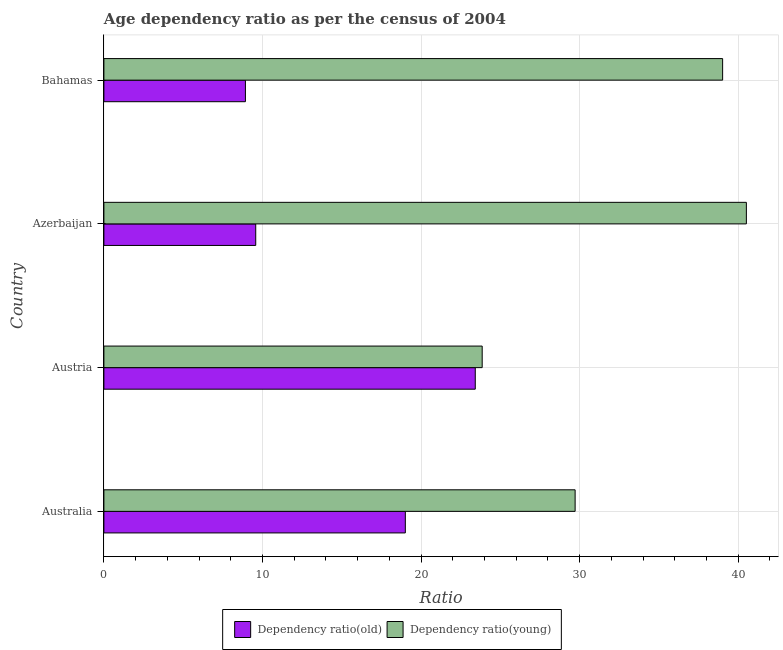Are the number of bars on each tick of the Y-axis equal?
Provide a succinct answer. Yes. How many bars are there on the 2nd tick from the top?
Your answer should be very brief. 2. How many bars are there on the 4th tick from the bottom?
Provide a succinct answer. 2. What is the age dependency ratio(young) in Austria?
Provide a short and direct response. 23.86. Across all countries, what is the maximum age dependency ratio(old)?
Make the answer very short. 23.42. Across all countries, what is the minimum age dependency ratio(young)?
Ensure brevity in your answer.  23.86. In which country was the age dependency ratio(young) maximum?
Offer a terse response. Azerbaijan. What is the total age dependency ratio(young) in the graph?
Provide a short and direct response. 133.12. What is the difference between the age dependency ratio(young) in Azerbaijan and that in Bahamas?
Make the answer very short. 1.5. What is the difference between the age dependency ratio(old) in Australia and the age dependency ratio(young) in Bahamas?
Offer a very short reply. -20.01. What is the average age dependency ratio(old) per country?
Ensure brevity in your answer.  15.23. What is the difference between the age dependency ratio(old) and age dependency ratio(young) in Azerbaijan?
Your answer should be very brief. -30.94. What is the ratio of the age dependency ratio(old) in Australia to that in Austria?
Ensure brevity in your answer.  0.81. What is the difference between the highest and the second highest age dependency ratio(young)?
Keep it short and to the point. 1.5. What is the difference between the highest and the lowest age dependency ratio(young)?
Ensure brevity in your answer.  16.66. In how many countries, is the age dependency ratio(old) greater than the average age dependency ratio(old) taken over all countries?
Give a very brief answer. 2. What does the 1st bar from the top in Australia represents?
Your response must be concise. Dependency ratio(young). What does the 2nd bar from the bottom in Austria represents?
Ensure brevity in your answer.  Dependency ratio(young). How many bars are there?
Your answer should be very brief. 8. What is the difference between two consecutive major ticks on the X-axis?
Provide a short and direct response. 10. Are the values on the major ticks of X-axis written in scientific E-notation?
Your answer should be very brief. No. Does the graph contain any zero values?
Keep it short and to the point. No. Where does the legend appear in the graph?
Offer a very short reply. Bottom center. What is the title of the graph?
Offer a very short reply. Age dependency ratio as per the census of 2004. What is the label or title of the X-axis?
Your response must be concise. Ratio. What is the Ratio of Dependency ratio(old) in Australia?
Offer a terse response. 19.01. What is the Ratio in Dependency ratio(young) in Australia?
Keep it short and to the point. 29.72. What is the Ratio in Dependency ratio(old) in Austria?
Your answer should be compact. 23.42. What is the Ratio of Dependency ratio(young) in Austria?
Keep it short and to the point. 23.86. What is the Ratio of Dependency ratio(old) in Azerbaijan?
Provide a succinct answer. 9.58. What is the Ratio in Dependency ratio(young) in Azerbaijan?
Ensure brevity in your answer.  40.52. What is the Ratio of Dependency ratio(old) in Bahamas?
Your answer should be very brief. 8.93. What is the Ratio of Dependency ratio(young) in Bahamas?
Make the answer very short. 39.02. Across all countries, what is the maximum Ratio in Dependency ratio(old)?
Provide a succinct answer. 23.42. Across all countries, what is the maximum Ratio of Dependency ratio(young)?
Keep it short and to the point. 40.52. Across all countries, what is the minimum Ratio of Dependency ratio(old)?
Your answer should be very brief. 8.93. Across all countries, what is the minimum Ratio of Dependency ratio(young)?
Offer a very short reply. 23.86. What is the total Ratio in Dependency ratio(old) in the graph?
Offer a terse response. 60.94. What is the total Ratio in Dependency ratio(young) in the graph?
Offer a very short reply. 133.12. What is the difference between the Ratio of Dependency ratio(old) in Australia and that in Austria?
Offer a terse response. -4.41. What is the difference between the Ratio in Dependency ratio(young) in Australia and that in Austria?
Your response must be concise. 5.86. What is the difference between the Ratio in Dependency ratio(old) in Australia and that in Azerbaijan?
Your response must be concise. 9.43. What is the difference between the Ratio in Dependency ratio(young) in Australia and that in Azerbaijan?
Offer a terse response. -10.8. What is the difference between the Ratio of Dependency ratio(old) in Australia and that in Bahamas?
Keep it short and to the point. 10.08. What is the difference between the Ratio in Dependency ratio(young) in Australia and that in Bahamas?
Your answer should be very brief. -9.3. What is the difference between the Ratio in Dependency ratio(old) in Austria and that in Azerbaijan?
Your answer should be very brief. 13.85. What is the difference between the Ratio in Dependency ratio(young) in Austria and that in Azerbaijan?
Offer a terse response. -16.66. What is the difference between the Ratio of Dependency ratio(old) in Austria and that in Bahamas?
Your answer should be very brief. 14.5. What is the difference between the Ratio in Dependency ratio(young) in Austria and that in Bahamas?
Give a very brief answer. -15.16. What is the difference between the Ratio of Dependency ratio(old) in Azerbaijan and that in Bahamas?
Keep it short and to the point. 0.65. What is the difference between the Ratio in Dependency ratio(young) in Azerbaijan and that in Bahamas?
Ensure brevity in your answer.  1.5. What is the difference between the Ratio in Dependency ratio(old) in Australia and the Ratio in Dependency ratio(young) in Austria?
Your answer should be compact. -4.85. What is the difference between the Ratio in Dependency ratio(old) in Australia and the Ratio in Dependency ratio(young) in Azerbaijan?
Your response must be concise. -21.51. What is the difference between the Ratio in Dependency ratio(old) in Australia and the Ratio in Dependency ratio(young) in Bahamas?
Offer a terse response. -20.01. What is the difference between the Ratio of Dependency ratio(old) in Austria and the Ratio of Dependency ratio(young) in Azerbaijan?
Give a very brief answer. -17.1. What is the difference between the Ratio of Dependency ratio(old) in Austria and the Ratio of Dependency ratio(young) in Bahamas?
Offer a very short reply. -15.6. What is the difference between the Ratio of Dependency ratio(old) in Azerbaijan and the Ratio of Dependency ratio(young) in Bahamas?
Your response must be concise. -29.45. What is the average Ratio of Dependency ratio(old) per country?
Make the answer very short. 15.23. What is the average Ratio of Dependency ratio(young) per country?
Ensure brevity in your answer.  33.28. What is the difference between the Ratio in Dependency ratio(old) and Ratio in Dependency ratio(young) in Australia?
Your response must be concise. -10.71. What is the difference between the Ratio of Dependency ratio(old) and Ratio of Dependency ratio(young) in Austria?
Your answer should be very brief. -0.44. What is the difference between the Ratio of Dependency ratio(old) and Ratio of Dependency ratio(young) in Azerbaijan?
Offer a terse response. -30.94. What is the difference between the Ratio in Dependency ratio(old) and Ratio in Dependency ratio(young) in Bahamas?
Give a very brief answer. -30.1. What is the ratio of the Ratio of Dependency ratio(old) in Australia to that in Austria?
Make the answer very short. 0.81. What is the ratio of the Ratio in Dependency ratio(young) in Australia to that in Austria?
Provide a succinct answer. 1.25. What is the ratio of the Ratio in Dependency ratio(old) in Australia to that in Azerbaijan?
Offer a terse response. 1.99. What is the ratio of the Ratio in Dependency ratio(young) in Australia to that in Azerbaijan?
Provide a short and direct response. 0.73. What is the ratio of the Ratio of Dependency ratio(old) in Australia to that in Bahamas?
Your answer should be very brief. 2.13. What is the ratio of the Ratio in Dependency ratio(young) in Australia to that in Bahamas?
Your answer should be compact. 0.76. What is the ratio of the Ratio in Dependency ratio(old) in Austria to that in Azerbaijan?
Your answer should be compact. 2.45. What is the ratio of the Ratio in Dependency ratio(young) in Austria to that in Azerbaijan?
Give a very brief answer. 0.59. What is the ratio of the Ratio of Dependency ratio(old) in Austria to that in Bahamas?
Offer a very short reply. 2.62. What is the ratio of the Ratio in Dependency ratio(young) in Austria to that in Bahamas?
Your answer should be compact. 0.61. What is the ratio of the Ratio of Dependency ratio(old) in Azerbaijan to that in Bahamas?
Offer a very short reply. 1.07. What is the ratio of the Ratio in Dependency ratio(young) in Azerbaijan to that in Bahamas?
Keep it short and to the point. 1.04. What is the difference between the highest and the second highest Ratio in Dependency ratio(old)?
Ensure brevity in your answer.  4.41. What is the difference between the highest and the second highest Ratio in Dependency ratio(young)?
Give a very brief answer. 1.5. What is the difference between the highest and the lowest Ratio in Dependency ratio(old)?
Make the answer very short. 14.5. What is the difference between the highest and the lowest Ratio in Dependency ratio(young)?
Provide a succinct answer. 16.66. 